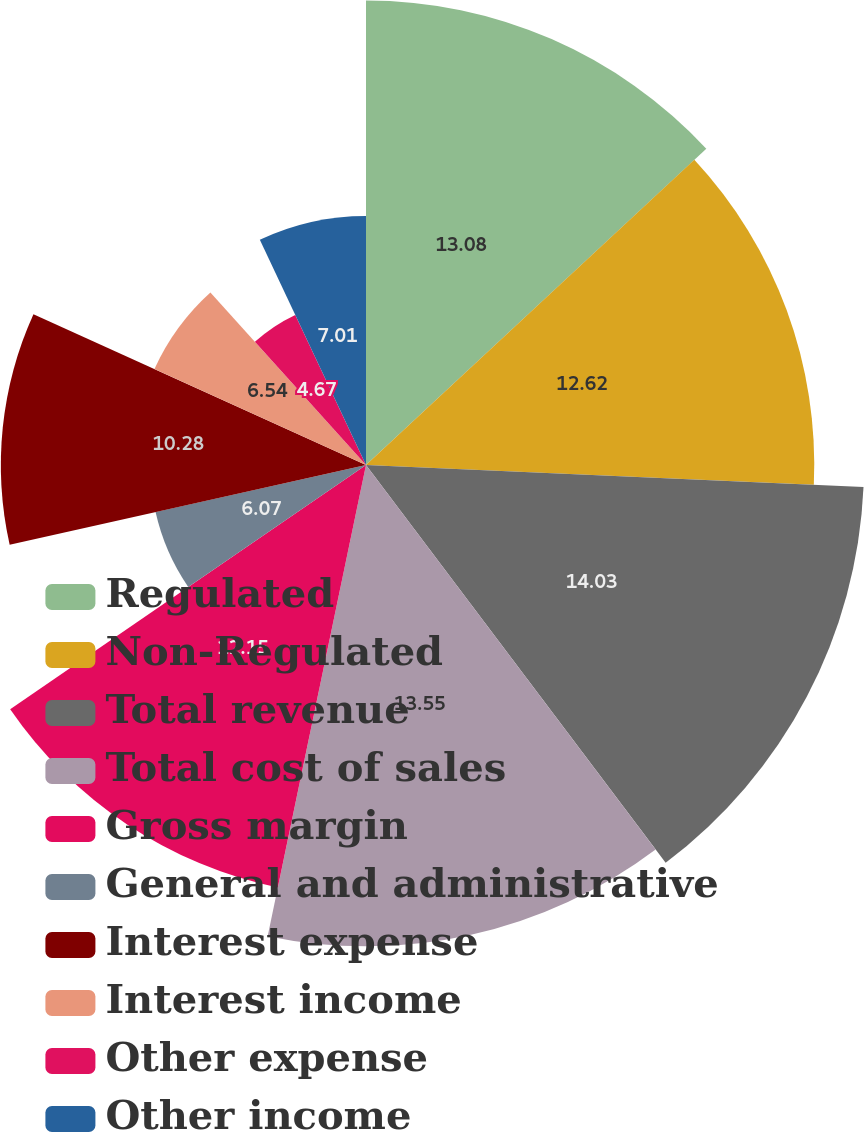Convert chart to OTSL. <chart><loc_0><loc_0><loc_500><loc_500><pie_chart><fcel>Regulated<fcel>Non-Regulated<fcel>Total revenue<fcel>Total cost of sales<fcel>Gross margin<fcel>General and administrative<fcel>Interest expense<fcel>Interest income<fcel>Other expense<fcel>Other income<nl><fcel>13.08%<fcel>12.62%<fcel>14.02%<fcel>13.55%<fcel>12.15%<fcel>6.07%<fcel>10.28%<fcel>6.54%<fcel>4.67%<fcel>7.01%<nl></chart> 